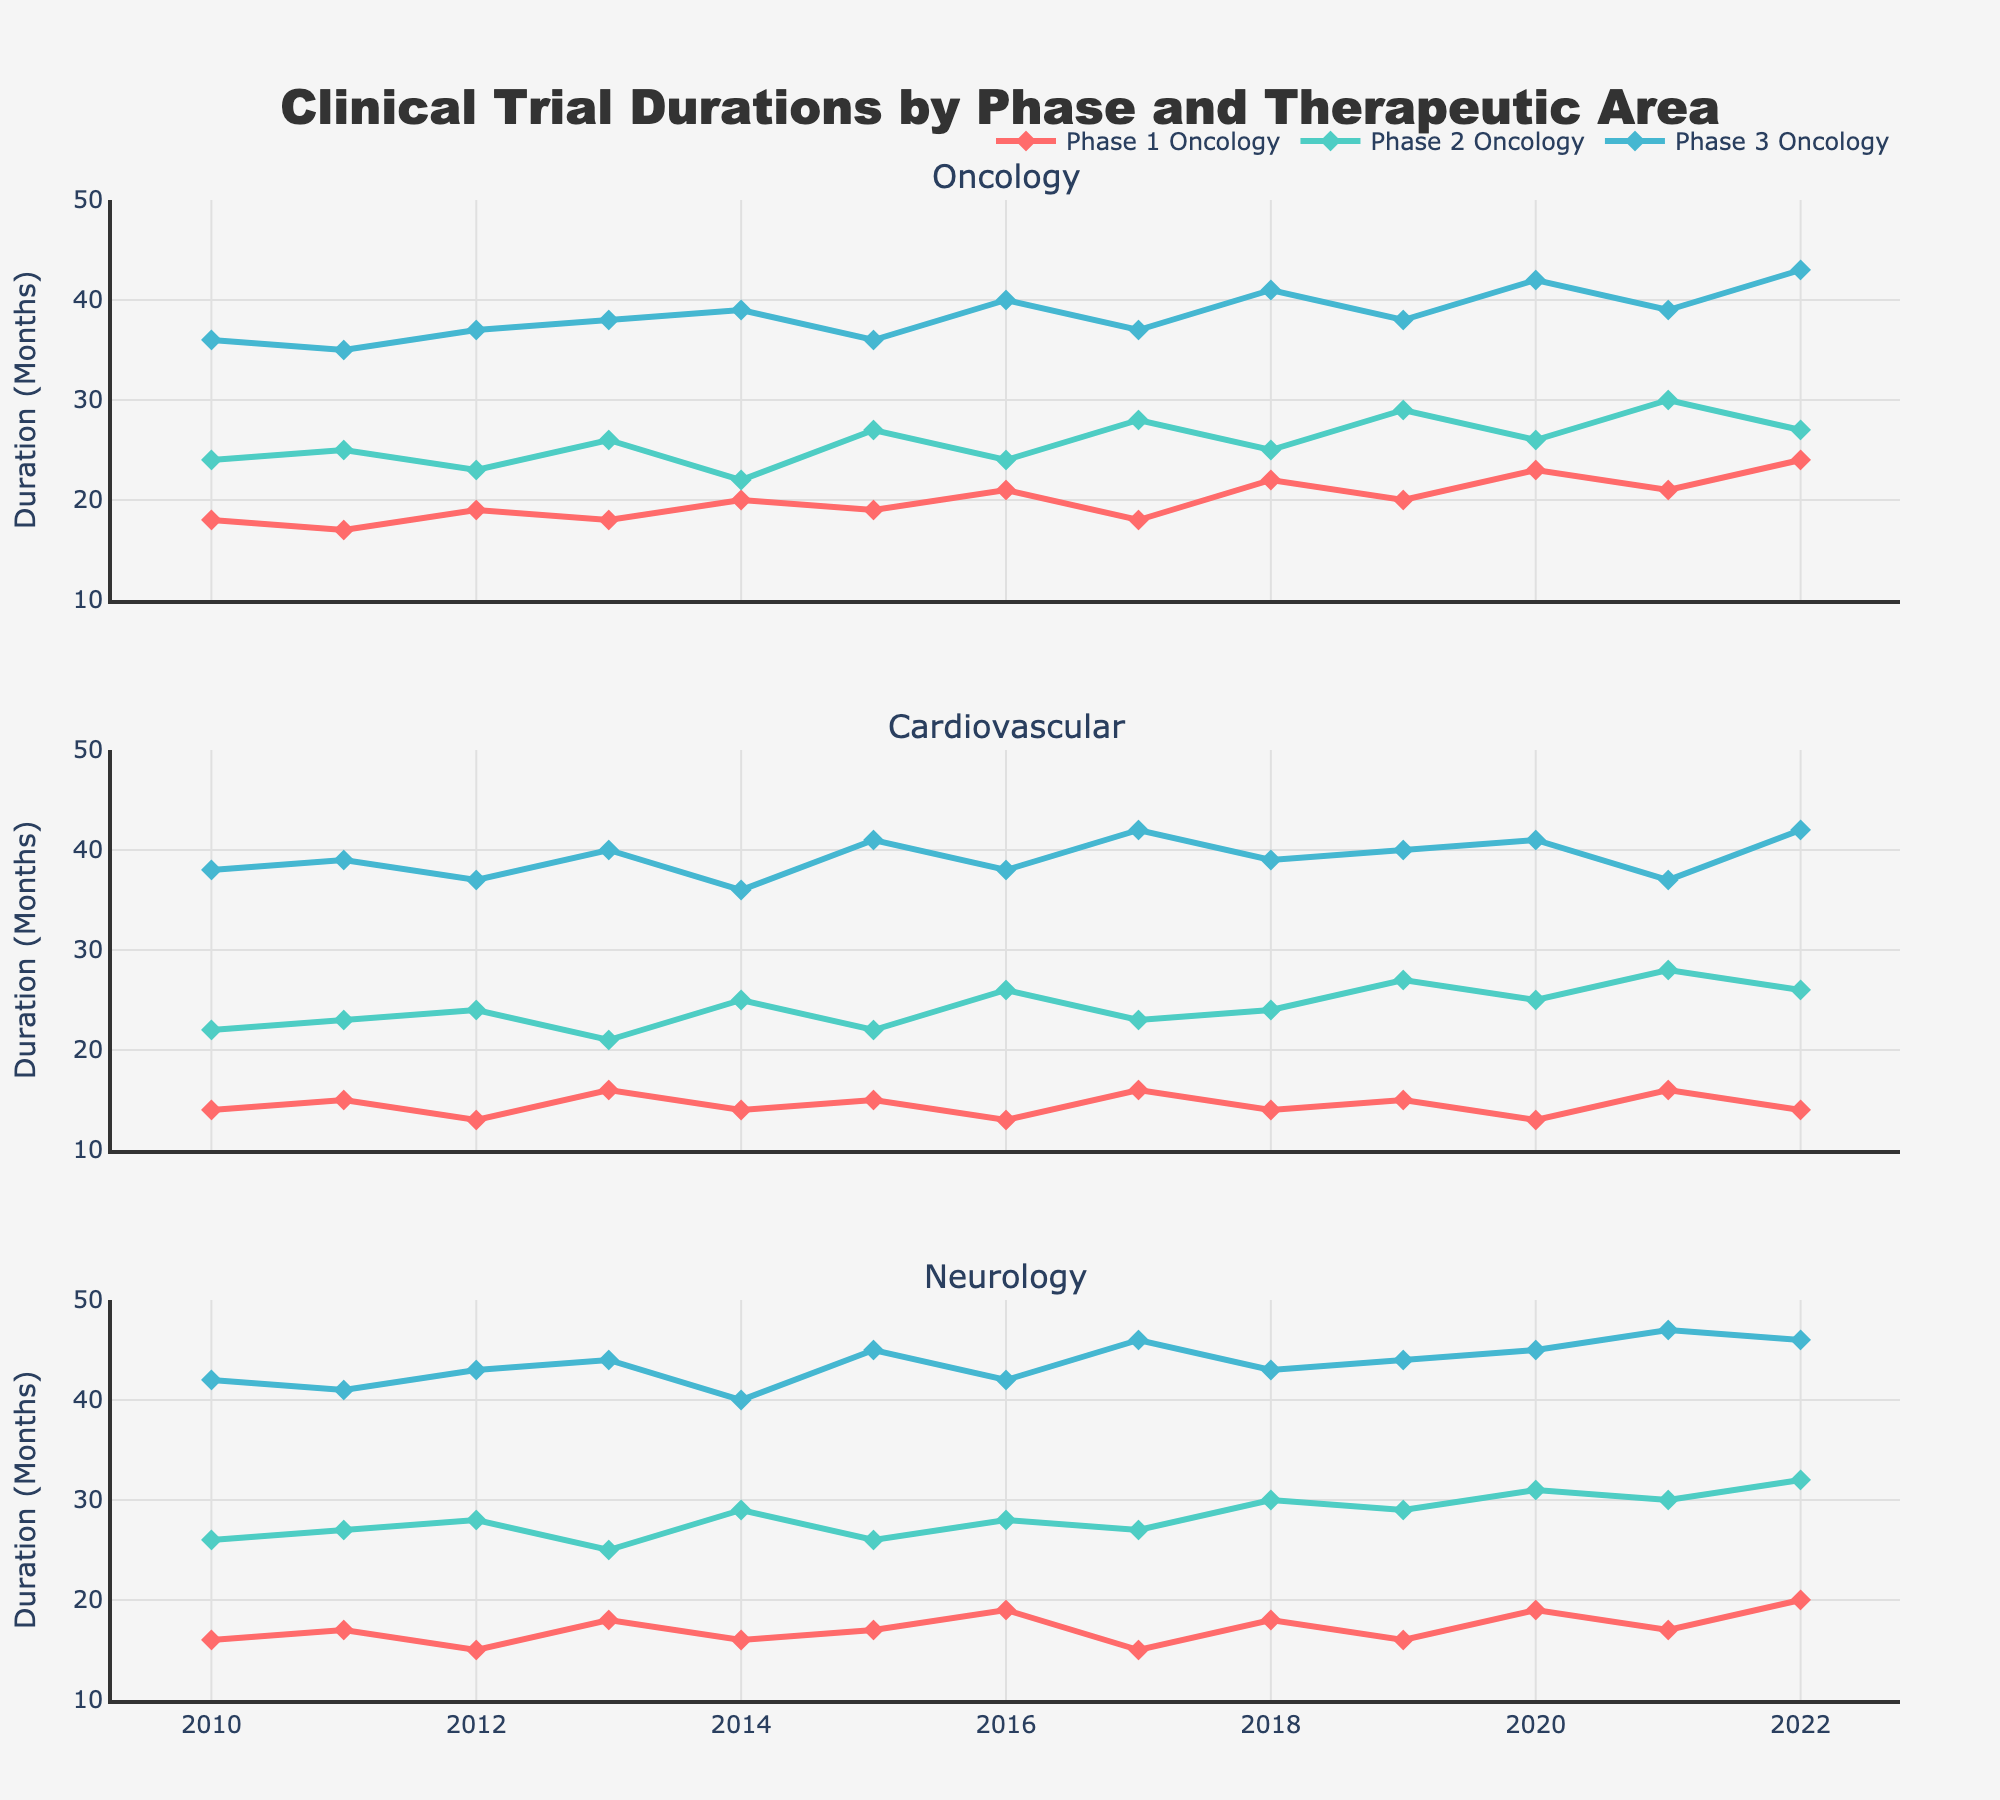Which therapeutic area had the longest Phase 3 trial duration in 2022? The top subplot, oncology, has Phase 3 marked in blue at a duration of 43 months; cardiovascular (middle subplot) shows 42 months; neurology (bottom subplot) shows 46 months.
Answer: Neurology Among Phase 2 trials in neurology, what was the average duration from 2010 to 2022? Identify the Phase 2 line (green) in neurology (bottom subplot) and list the values for each year: 26, 27, 28, 25, 29, 26, 28, 27, 30, 29, 31, 30, 32. Sum these (28*13=364) and divide by 13.
Answer: 28 months In 2020, which therapeutic area had the shortest Phase 1 trial duration? For 2020, compare Phase 1 markers (red): oncology at 23, cardiovascular at 13, neurology at 19.
Answer: Cardiovascular How did the duration of Phase 2 oncology trials change from 2010 to 2011? Identify oncology Phase 2 (green) in the top subplot; duration was 24 months in 2010 and 25 months in 2011. Subtract 24 from 25.
Answer: Increased by 1 month What is the range of Phase 3 cardiovascular trial durations from 2010 to 2022? Identify Phase 3 cardiovascular (blue) in the middle subplot, with durations from 36 to 42 months. The range is the difference between the maximum (42) and minimum (36).
Answer: 6 months From 2010 to 2022, what is the overall trend in Phase 1 oncology trial durations? Phase 1 oncology (red) in the top subplot shows increasing and decreasing fluctuations but a general upward trend from 18 (2010) to 24 (2022).
Answer: Upward trend Which year had the highest increase in Phase 3 neurology trial duration compared to the previous year? Analyze the differences year-over-year for Phase 3 neurology (blue, bottom subplot): 42-41 (2011 to 2012), 44-43 (2012 to 2013), and so on. The largest increase is from 2017 (46) to 2021 (47).
Answer: 2021 In 2015, how much longer were Phase 3 oncology trials compared to Phase 3 neurology trials? Oncology Phase 3 (blue, top subplot) shows 36 months, while neurology Phase 3 (blue, bottom subplot) shows 45 months in 2015. Subtract 36 from 45.
Answer: 9 months 